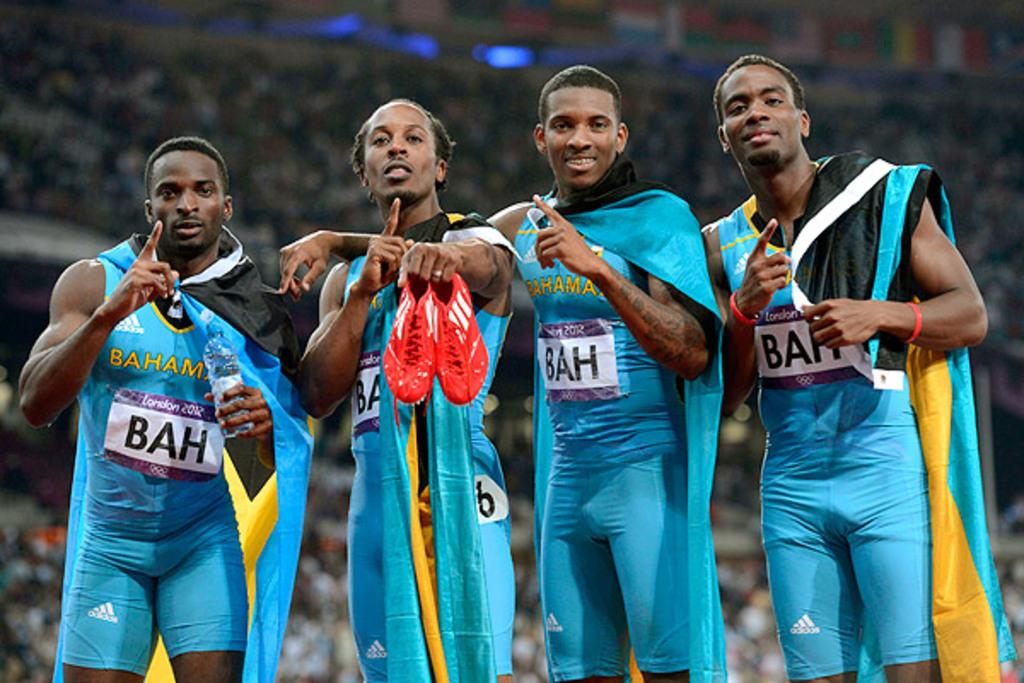<image>
Relay a brief, clear account of the picture shown. One of the athletes from the Bahamas is holding a pair of red running shoes. 